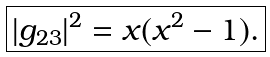<formula> <loc_0><loc_0><loc_500><loc_500>\boxed { | g _ { 2 3 } | ^ { 2 } = x ( x ^ { 2 } - 1 ) . }</formula> 